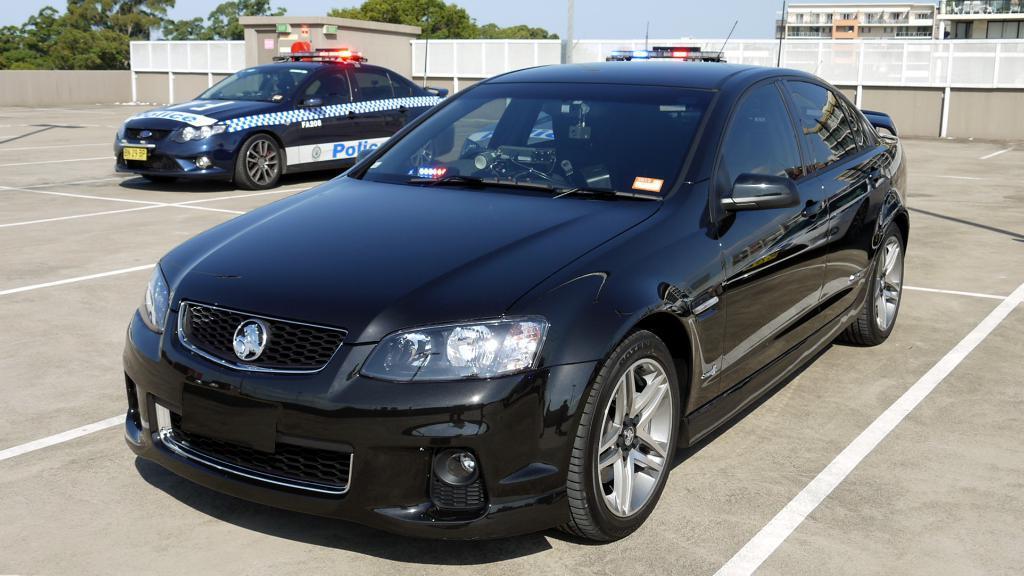Could you give a brief overview of what you see in this image? In this image we can see the vehicles. And we can see a shed and the metal fencing. And we can see the trees and the sky. 